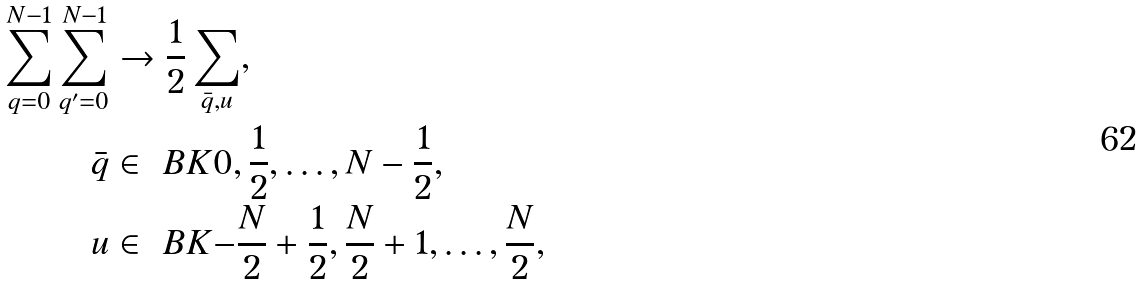Convert formula to latex. <formula><loc_0><loc_0><loc_500><loc_500>\sum _ { q = 0 } ^ { N - 1 } \sum _ { q ^ { \prime } = 0 } ^ { N - 1 } & \to \frac { 1 } { 2 } \sum _ { \bar { q } , u } , \\ \bar { q } & \in \ B K { 0 , \frac { 1 } { 2 } , \dots , N - \frac { 1 } { 2 } } , \\ u & \in \ B K { - \frac { N } { 2 } + \frac { 1 } { 2 } , \frac { N } { 2 } + 1 , \dots , \frac { N } { 2 } } ,</formula> 